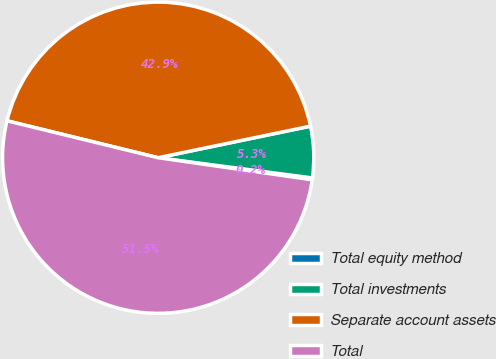<chart> <loc_0><loc_0><loc_500><loc_500><pie_chart><fcel>Total equity method<fcel>Total investments<fcel>Separate account assets<fcel>Total<nl><fcel>0.19%<fcel>5.33%<fcel>42.93%<fcel>51.55%<nl></chart> 